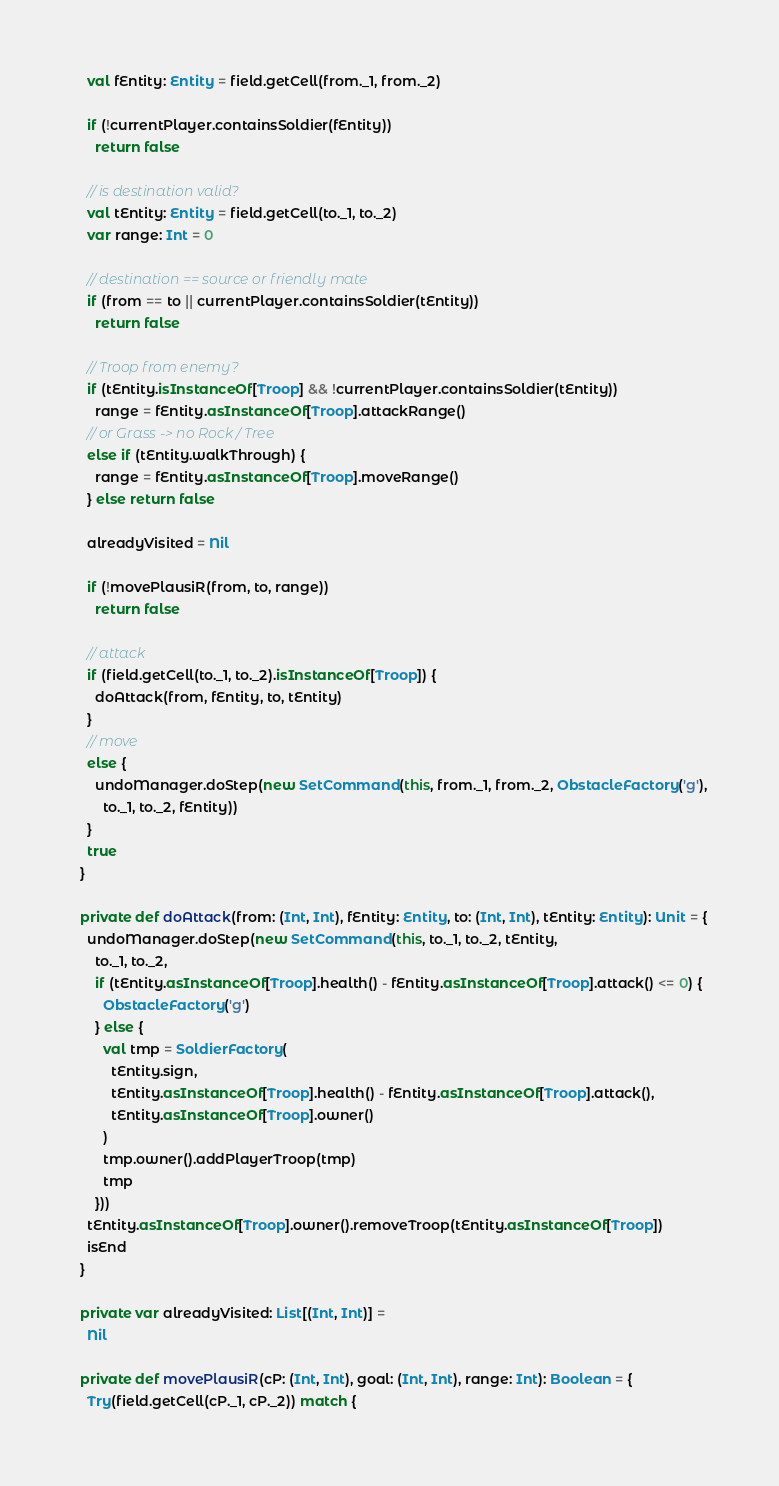<code> <loc_0><loc_0><loc_500><loc_500><_Scala_>    val fEntity: Entity = field.getCell(from._1, from._2)

    if (!currentPlayer.containsSoldier(fEntity))
      return false

    // is destination valid?
    val tEntity: Entity = field.getCell(to._1, to._2)
    var range: Int = 0

    // destination == source or friendly mate
    if (from == to || currentPlayer.containsSoldier(tEntity))
      return false

    // Troop from enemy?
    if (tEntity.isInstanceOf[Troop] && !currentPlayer.containsSoldier(tEntity))
      range = fEntity.asInstanceOf[Troop].attackRange()
    // or Grass -> no Rock / Tree
    else if (tEntity.walkThrough) {
      range = fEntity.asInstanceOf[Troop].moveRange()
    } else return false

    alreadyVisited = Nil

    if (!movePlausiR(from, to, range))
      return false

    // attack
    if (field.getCell(to._1, to._2).isInstanceOf[Troop]) {
      doAttack(from, fEntity, to, tEntity)
    }
    // move
    else {
      undoManager.doStep(new SetCommand(this, from._1, from._2, ObstacleFactory('g'),
        to._1, to._2, fEntity))
    }
    true
  }

  private def doAttack(from: (Int, Int), fEntity: Entity, to: (Int, Int), tEntity: Entity): Unit = {
    undoManager.doStep(new SetCommand(this, to._1, to._2, tEntity,
      to._1, to._2,
      if (tEntity.asInstanceOf[Troop].health() - fEntity.asInstanceOf[Troop].attack() <= 0) {
        ObstacleFactory('g')
      } else {
        val tmp = SoldierFactory(
          tEntity.sign,
          tEntity.asInstanceOf[Troop].health() - fEntity.asInstanceOf[Troop].attack(),
          tEntity.asInstanceOf[Troop].owner()
        )
        tmp.owner().addPlayerTroop(tmp)
        tmp
      }))
    tEntity.asInstanceOf[Troop].owner().removeTroop(tEntity.asInstanceOf[Troop])
    isEnd
  }

  private var alreadyVisited: List[(Int, Int)] =
    Nil

  private def movePlausiR(cP: (Int, Int), goal: (Int, Int), range: Int): Boolean = {
    Try(field.getCell(cP._1, cP._2)) match {</code> 